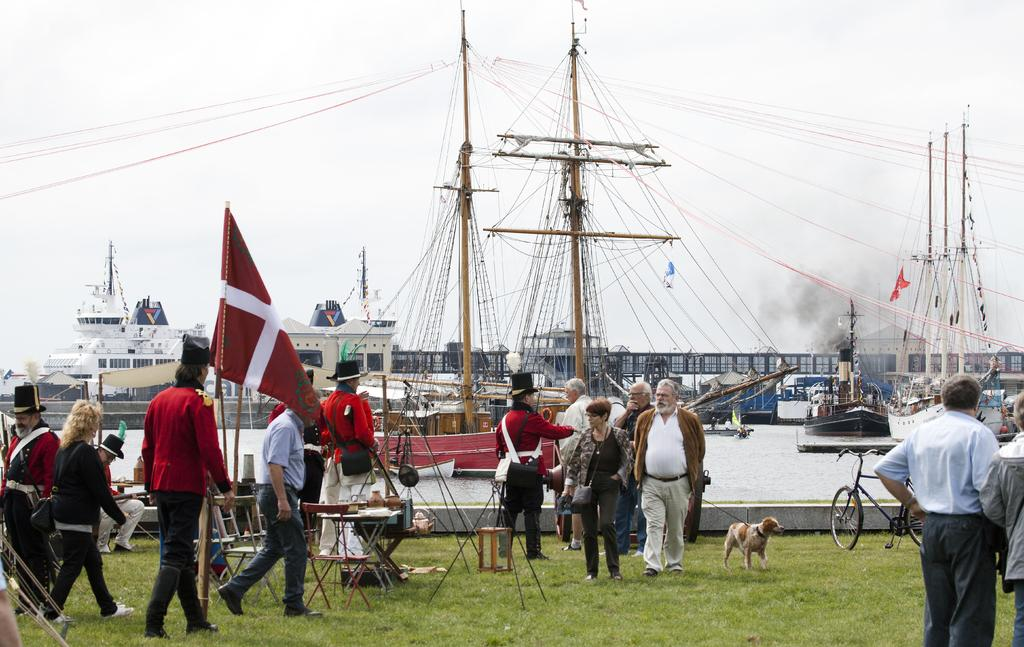What is the surface that the people are standing on in the image? The people are standing on the grass. What can be seen in the background of the image? Ships are visible in the background. What is the rate at which the stage is moving in the image? There is no stage present in the image, so it is not possible to determine the rate at which it might be moving. 